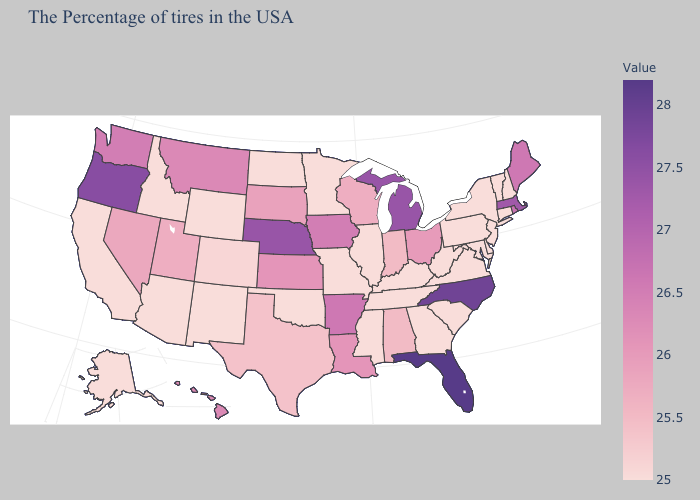Does Florida have the highest value in the USA?
Concise answer only. Yes. Which states have the lowest value in the Northeast?
Short answer required. New Hampshire, Vermont, Connecticut, New York, New Jersey, Pennsylvania. Which states have the lowest value in the West?
Short answer required. Wyoming, New Mexico, Arizona, Idaho, California, Alaska. Does Rhode Island have the lowest value in the Northeast?
Write a very short answer. No. Does Wisconsin have the highest value in the USA?
Give a very brief answer. No. Does South Carolina have the highest value in the USA?
Write a very short answer. No. 